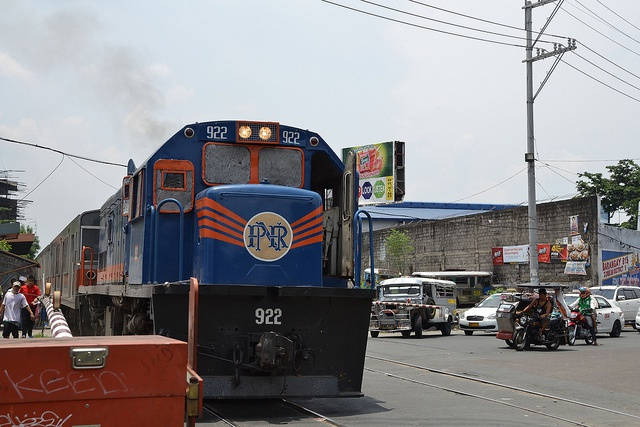Describe the objects in this image and their specific colors. I can see train in lightgray, black, navy, gray, and darkgray tones, truck in lightgray, black, gray, darkgray, and white tones, motorcycle in lightgray, black, gray, and darkgray tones, car in lightgray, white, darkgray, black, and gray tones, and people in lightgray, black, darkgray, and gray tones in this image. 